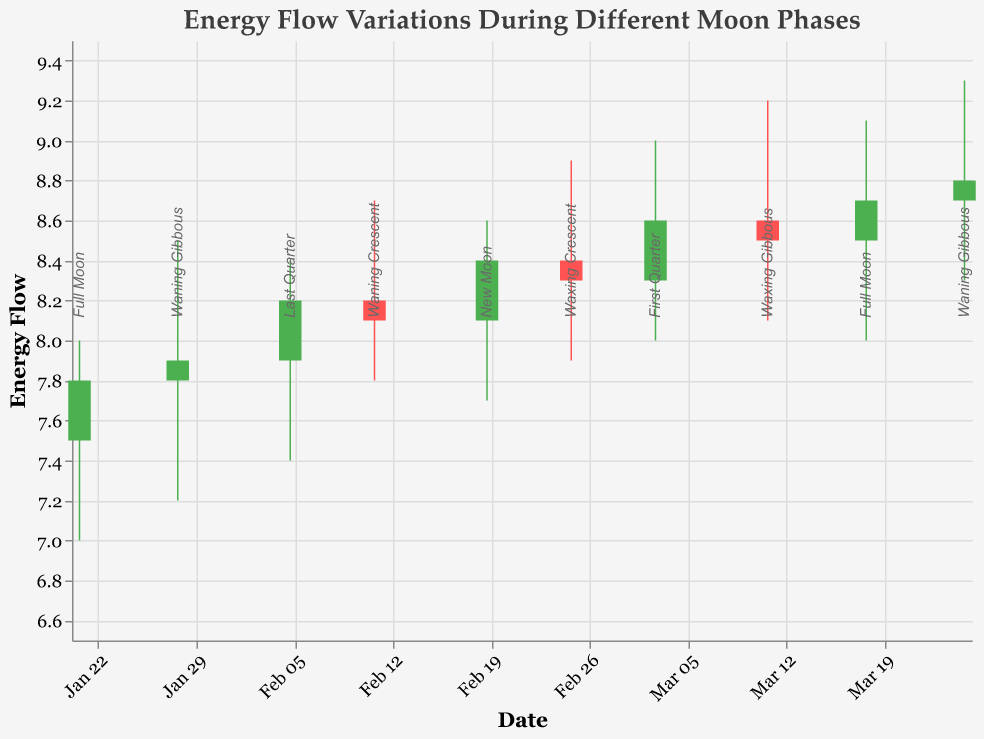What's the title of the figure? The text at the top of the figure states the title, which is "Energy Flow Variations During Different Moon Phases".
Answer: Energy Flow Variations During Different Moon Phases Which date shows the highest High value? By examining the High values along the vertical axis for each date, we see that the highest value is on March 11, 2023.
Answer: March 11, 2023 What were the Open and Close values on the New Moon date? The New Moon corresponds to February 19, 2023. The figure shows an Open value of 8.1 and a Close value of 8.4 on this date.
Answer: Open: 8.1, Close: 8.4 Compare the Open values on the two Full Moon dates. Which one is higher? The Full Moon dates are January 21, 2023, and March 18, 2023. The Open values are 7.5 and 8.5 respectively. Comparing these, 8.5 is higher.
Answer: March 18, 2023 Which moon phase shows the largest difference between High and Low values? Calculate the difference for each date by subtracting Low from High. The largest difference is on January 28, 2023 (8.5 - 7.2 = 1.3).
Answer: Waning Gibbous Describe the trend of Close values from January 21, 2023, to March 25, 2023. Observing the progression of Close values, we see a general increasing trend starting from 7.8 on January 21 to 8.8 on March 25.
Answer: Increasing trend On which date does the Close value equal the Open value? By examining the Open and Close values for each date, there is no instance where Close equals Open.
Answer: None List all dates where the energy flow increased from Open to Close. Check dates where Open < Close: January 21, February 5, February 19, March 3, March 18, and March 25.
Answer: January 21, February 5, February 19, March 3, March 18, March 25 What is the average Close value during all mentioned moon phases? Sum all Close values and divide by the number of entries: (7.8 + 7.9 + 8.2 + 8.1 + 8.4 + 8.3 + 8.6 + 8.5 + 8.7 + 8.8) / 10 = 8.33
Answer: 8.33 